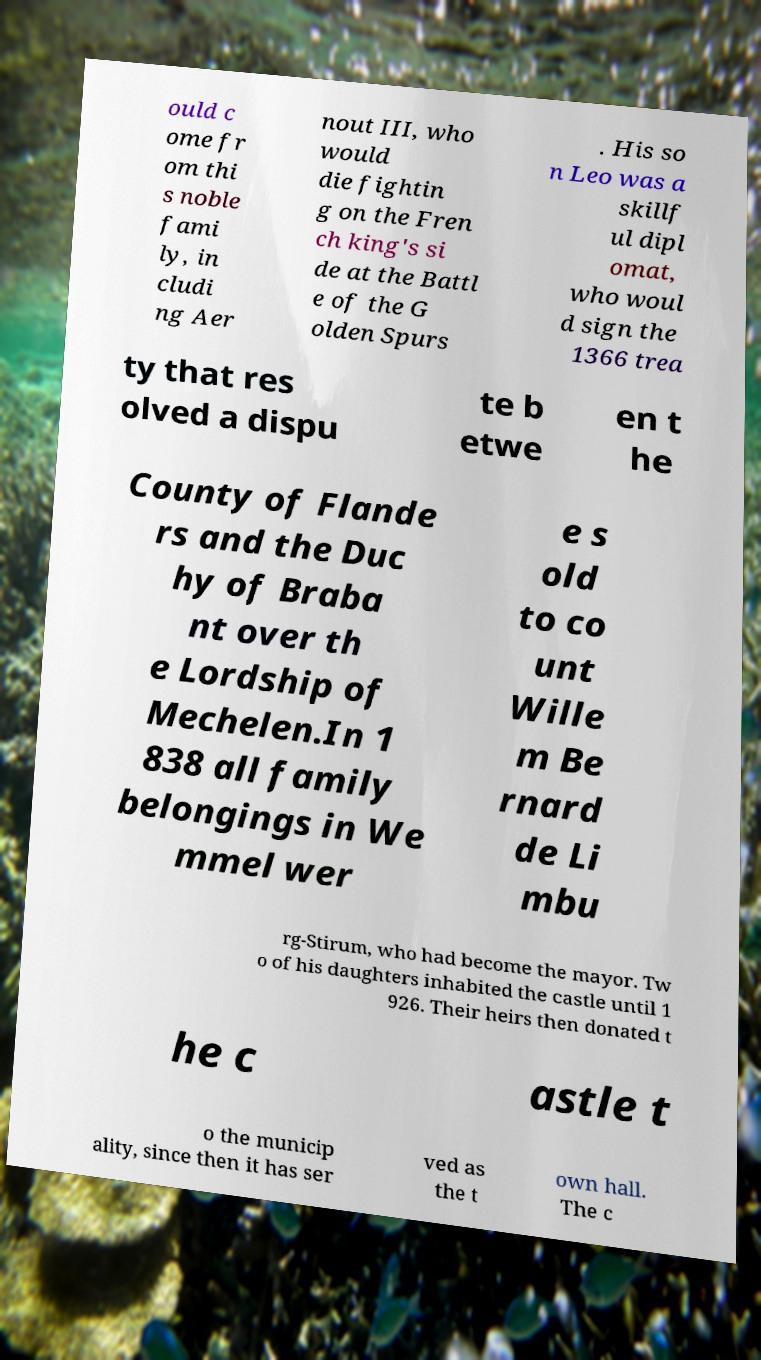For documentation purposes, I need the text within this image transcribed. Could you provide that? ould c ome fr om thi s noble fami ly, in cludi ng Aer nout III, who would die fightin g on the Fren ch king's si de at the Battl e of the G olden Spurs . His so n Leo was a skillf ul dipl omat, who woul d sign the 1366 trea ty that res olved a dispu te b etwe en t he County of Flande rs and the Duc hy of Braba nt over th e Lordship of Mechelen.In 1 838 all family belongings in We mmel wer e s old to co unt Wille m Be rnard de Li mbu rg-Stirum, who had become the mayor. Tw o of his daughters inhabited the castle until 1 926. Their heirs then donated t he c astle t o the municip ality, since then it has ser ved as the t own hall. The c 